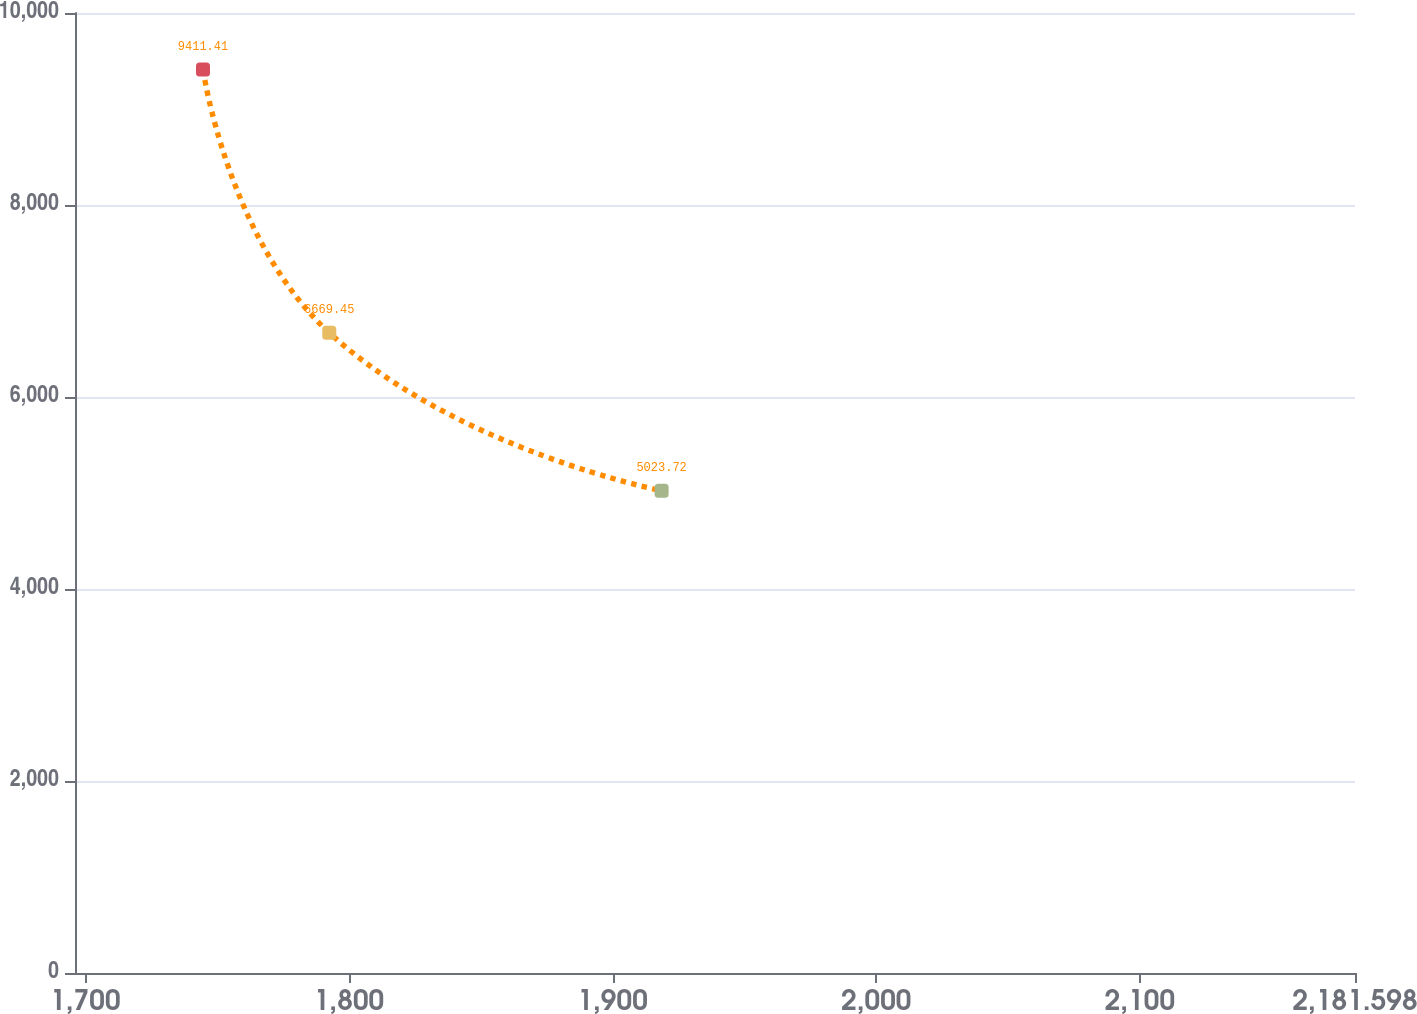Convert chart to OTSL. <chart><loc_0><loc_0><loc_500><loc_500><line_chart><ecel><fcel>Unnamed: 1<nl><fcel>1744.63<fcel>9411.41<nl><fcel>1792.53<fcel>6669.45<nl><fcel>1918.59<fcel>5023.72<nl><fcel>2182.25<fcel>3960.43<nl><fcel>2230.15<fcel>3354.76<nl></chart> 